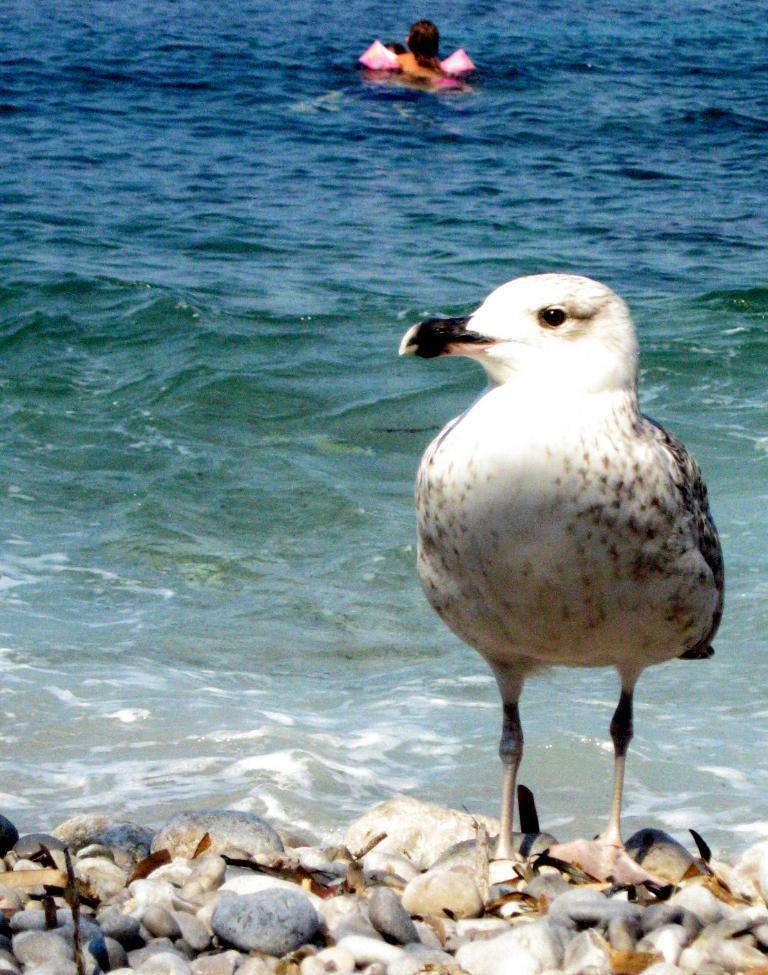Can you describe this image briefly? A bird is on the stones, this is water, here people are swimming. 